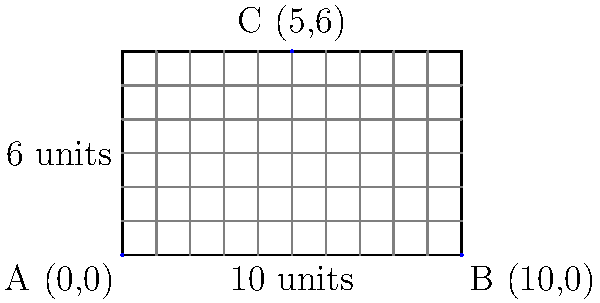As a business owner, you need to install security cameras to cover your rectangular establishment. The store measures 10 units in length and 6 units in width. You decide to place three cameras: one at each of the bottom corners (0,0) and (10,0), and one at the midpoint of the top edge (5,6). What is the total area of the triangular region formed by connecting these three camera positions? Let's approach this step-by-step:

1) We have a triangle with vertices at (0,0), (10,0), and (5,6).

2) To find the area of a triangle given its vertices, we can use the formula:
   
   Area = $\frac{1}{2}|x_1(y_2 - y_3) + x_2(y_3 - y_1) + x_3(y_1 - y_2)|$

   Where $(x_1,y_1)$, $(x_2,y_2)$, and $(x_3,y_3)$ are the coordinates of the three vertices.

3) Let's assign our points:
   $(x_1,y_1) = (0,0)$
   $(x_2,y_2) = (10,0)$
   $(x_3,y_3) = (5,6)$

4) Now, let's substitute these into our formula:

   Area = $\frac{1}{2}|0(0 - 6) + 10(6 - 0) + 5(0 - 0)|$

5) Simplify:
   Area = $\frac{1}{2}|0 + 60 + 0|$
   Area = $\frac{1}{2}(60)$
   Area = 30

6) Therefore, the area of the triangle is 30 square units.
Answer: 30 square units 